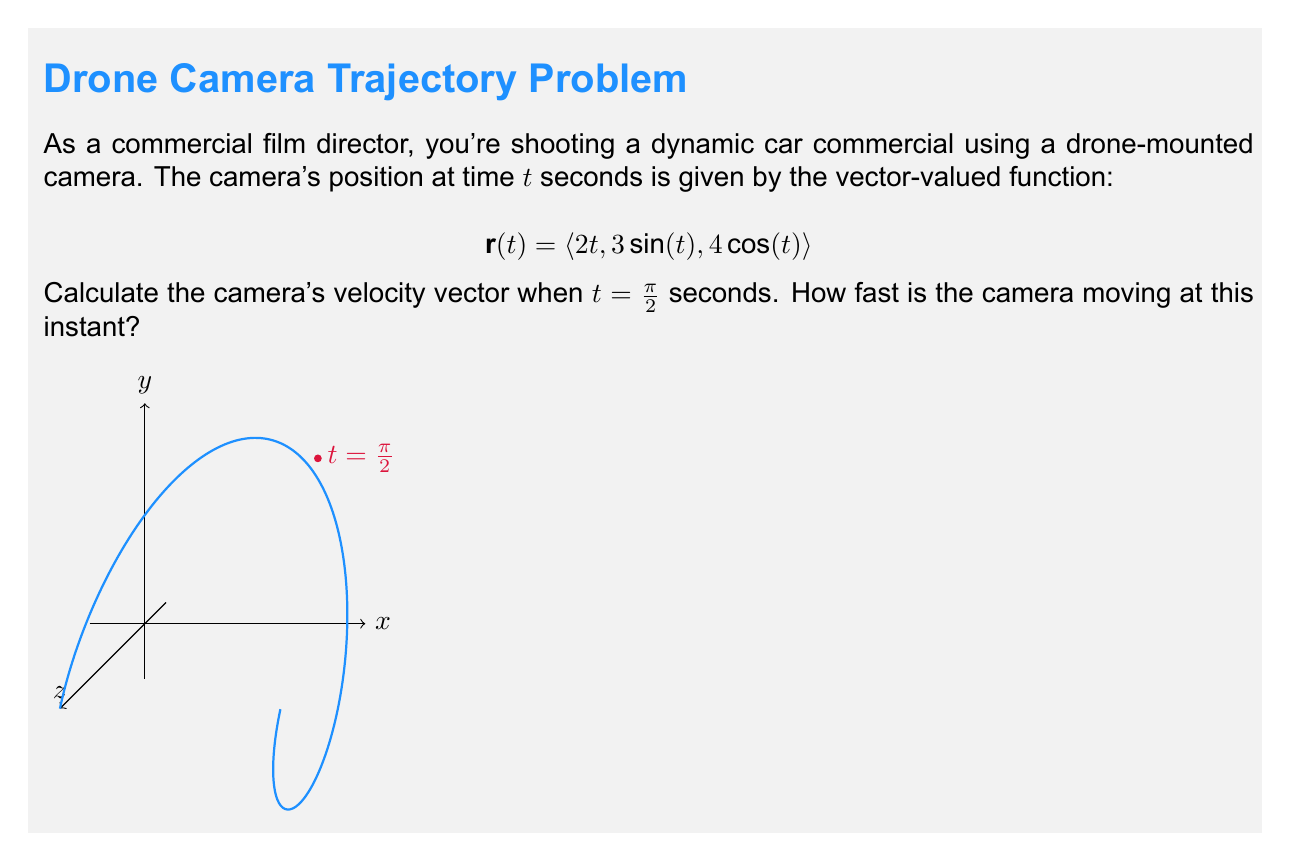What is the answer to this math problem? Let's approach this step-by-step:

1) The velocity vector is the derivative of the position vector with respect to time. So, we need to find $\mathbf{r}'(t)$.

2) $\mathbf{r}(t) = \langle 2t, 3\sin(t), 4\cos(t) \rangle$

3) Differentiating each component:
   $\mathbf{r}'(t) = \langle 2, 3\cos(t), -4\sin(t) \rangle$

4) We need to evaluate this at $t = \frac{\pi}{2}$:
   $\mathbf{r}'(\frac{\pi}{2}) = \langle 2, 3\cos(\frac{\pi}{2}), -4\sin(\frac{\pi}{2}) \rangle$

5) Simplify:
   $\cos(\frac{\pi}{2}) = 0$ and $\sin(\frac{\pi}{2}) = 1$
   So, $\mathbf{r}'(\frac{\pi}{2}) = \langle 2, 0, -4 \rangle$

6) This is the velocity vector at $t = \frac{\pi}{2}$.

7) To find the speed (how fast the camera is moving), we calculate the magnitude of the velocity vector:

   $\text{Speed} = \|\mathbf{r}'(\frac{\pi}{2})\| = \sqrt{2^2 + 0^2 + (-4)^2} = \sqrt{4 + 16} = \sqrt{20} = 2\sqrt{5}$

Therefore, the camera's velocity vector at $t = \frac{\pi}{2}$ is $\langle 2, 0, -4 \rangle$, and its speed at this instant is $2\sqrt{5}$ units per second.
Answer: Velocity vector: $\langle 2, 0, -4 \rangle$; Speed: $2\sqrt{5}$ units/s 